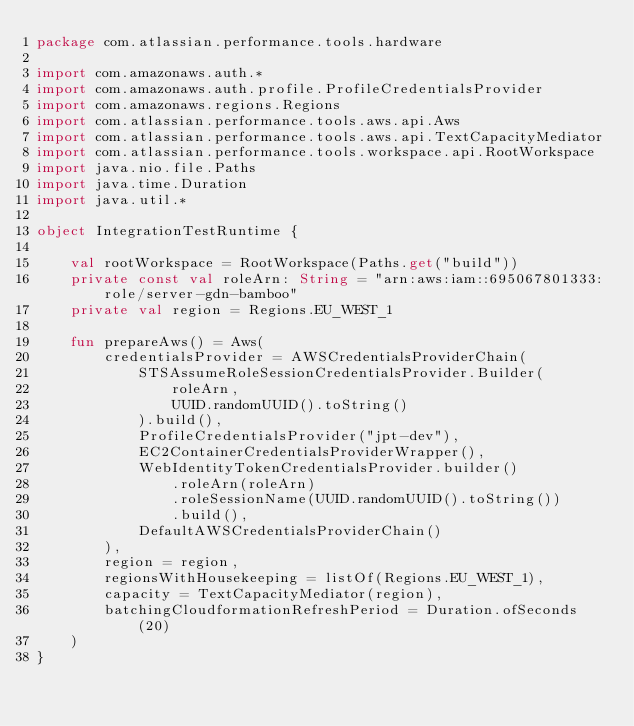Convert code to text. <code><loc_0><loc_0><loc_500><loc_500><_Kotlin_>package com.atlassian.performance.tools.hardware

import com.amazonaws.auth.*
import com.amazonaws.auth.profile.ProfileCredentialsProvider
import com.amazonaws.regions.Regions
import com.atlassian.performance.tools.aws.api.Aws
import com.atlassian.performance.tools.aws.api.TextCapacityMediator
import com.atlassian.performance.tools.workspace.api.RootWorkspace
import java.nio.file.Paths
import java.time.Duration
import java.util.*

object IntegrationTestRuntime {

    val rootWorkspace = RootWorkspace(Paths.get("build"))
    private const val roleArn: String = "arn:aws:iam::695067801333:role/server-gdn-bamboo"
    private val region = Regions.EU_WEST_1

    fun prepareAws() = Aws(
        credentialsProvider = AWSCredentialsProviderChain(
            STSAssumeRoleSessionCredentialsProvider.Builder(
                roleArn,
                UUID.randomUUID().toString()
            ).build(),
            ProfileCredentialsProvider("jpt-dev"),
            EC2ContainerCredentialsProviderWrapper(),
            WebIdentityTokenCredentialsProvider.builder()
                .roleArn(roleArn)
                .roleSessionName(UUID.randomUUID().toString())
                .build(),
            DefaultAWSCredentialsProviderChain()
        ),
        region = region,
        regionsWithHousekeeping = listOf(Regions.EU_WEST_1),
        capacity = TextCapacityMediator(region),
        batchingCloudformationRefreshPeriod = Duration.ofSeconds(20)
    )
}
</code> 